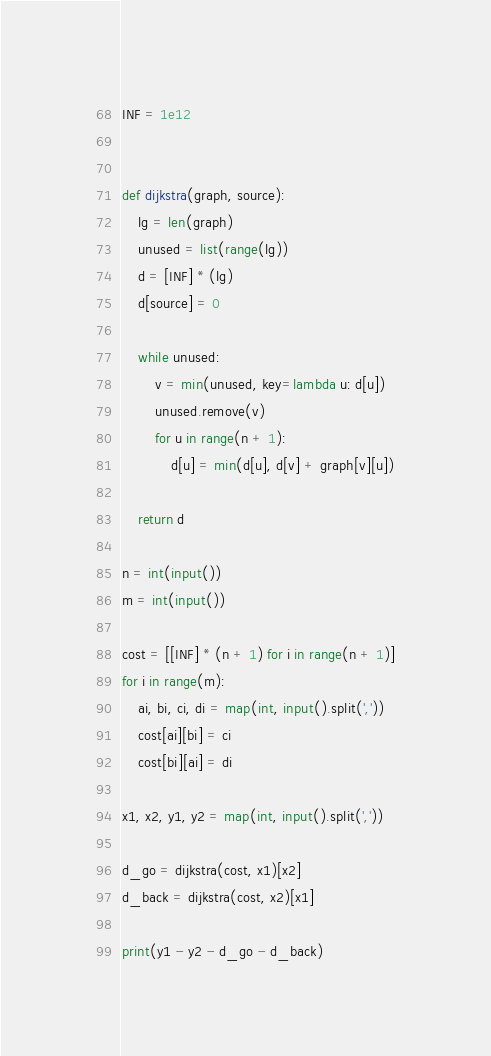<code> <loc_0><loc_0><loc_500><loc_500><_Python_>INF = 1e12


def dijkstra(graph, source):
    lg = len(graph)
    unused = list(range(lg))
    d = [INF] * (lg)
    d[source] = 0

    while unused:
        v = min(unused, key=lambda u: d[u])
        unused.remove(v)
        for u in range(n + 1):
            d[u] = min(d[u], d[v] + graph[v][u])

    return d

n = int(input())
m = int(input())

cost = [[INF] * (n + 1) for i in range(n + 1)]
for i in range(m):
    ai, bi, ci, di = map(int, input().split(','))
    cost[ai][bi] = ci
    cost[bi][ai] = di

x1, x2, y1, y2 = map(int, input().split(','))

d_go = dijkstra(cost, x1)[x2]
d_back = dijkstra(cost, x2)[x1]

print(y1 - y2 - d_go - d_back)</code> 